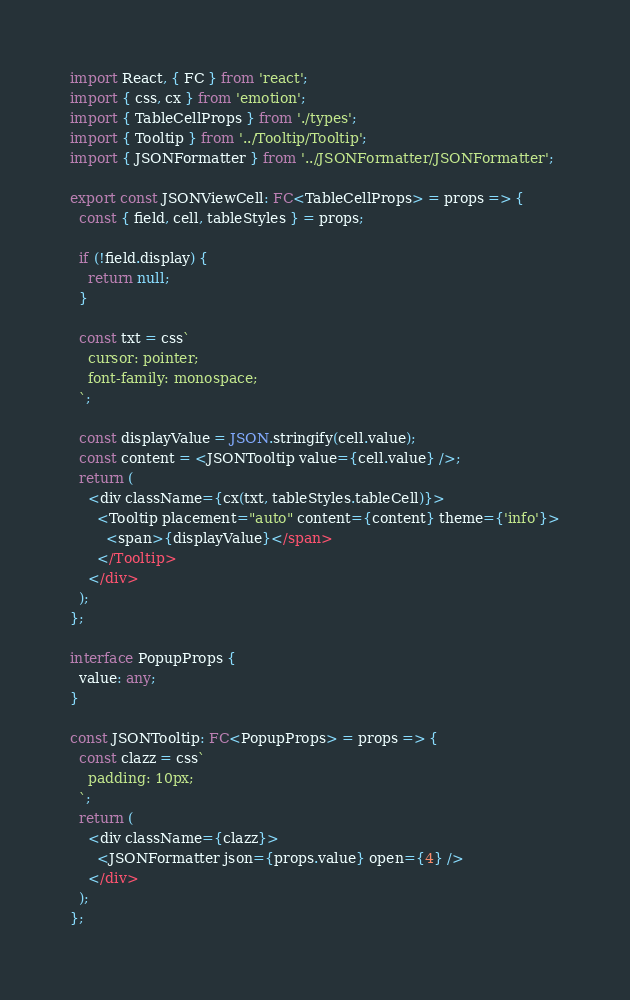<code> <loc_0><loc_0><loc_500><loc_500><_TypeScript_>import React, { FC } from 'react';
import { css, cx } from 'emotion';
import { TableCellProps } from './types';
import { Tooltip } from '../Tooltip/Tooltip';
import { JSONFormatter } from '../JSONFormatter/JSONFormatter';

export const JSONViewCell: FC<TableCellProps> = props => {
  const { field, cell, tableStyles } = props;

  if (!field.display) {
    return null;
  }

  const txt = css`
    cursor: pointer;
    font-family: monospace;
  `;

  const displayValue = JSON.stringify(cell.value);
  const content = <JSONTooltip value={cell.value} />;
  return (
    <div className={cx(txt, tableStyles.tableCell)}>
      <Tooltip placement="auto" content={content} theme={'info'}>
        <span>{displayValue}</span>
      </Tooltip>
    </div>
  );
};

interface PopupProps {
  value: any;
}

const JSONTooltip: FC<PopupProps> = props => {
  const clazz = css`
    padding: 10px;
  `;
  return (
    <div className={clazz}>
      <JSONFormatter json={props.value} open={4} />
    </div>
  );
};
</code> 